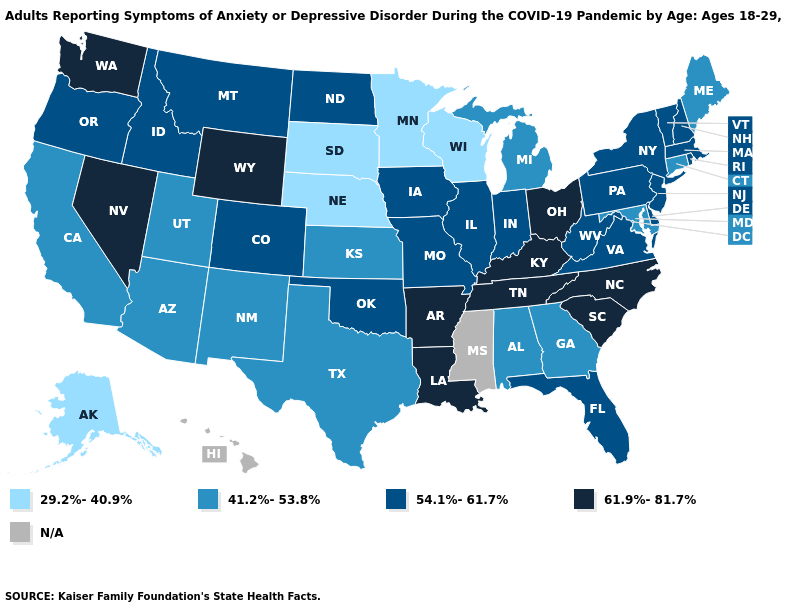What is the lowest value in the Northeast?
Keep it brief. 41.2%-53.8%. Which states have the lowest value in the USA?
Give a very brief answer. Alaska, Minnesota, Nebraska, South Dakota, Wisconsin. Which states have the lowest value in the USA?
Short answer required. Alaska, Minnesota, Nebraska, South Dakota, Wisconsin. Name the states that have a value in the range 54.1%-61.7%?
Give a very brief answer. Colorado, Delaware, Florida, Idaho, Illinois, Indiana, Iowa, Massachusetts, Missouri, Montana, New Hampshire, New Jersey, New York, North Dakota, Oklahoma, Oregon, Pennsylvania, Rhode Island, Vermont, Virginia, West Virginia. What is the highest value in the Northeast ?
Give a very brief answer. 54.1%-61.7%. What is the value of Hawaii?
Be succinct. N/A. Among the states that border Arizona , does Nevada have the lowest value?
Short answer required. No. Among the states that border Indiana , which have the lowest value?
Write a very short answer. Michigan. Is the legend a continuous bar?
Give a very brief answer. No. Among the states that border Rhode Island , which have the lowest value?
Answer briefly. Connecticut. Name the states that have a value in the range 54.1%-61.7%?
Answer briefly. Colorado, Delaware, Florida, Idaho, Illinois, Indiana, Iowa, Massachusetts, Missouri, Montana, New Hampshire, New Jersey, New York, North Dakota, Oklahoma, Oregon, Pennsylvania, Rhode Island, Vermont, Virginia, West Virginia. What is the value of North Dakota?
Short answer required. 54.1%-61.7%. What is the highest value in the USA?
Keep it brief. 61.9%-81.7%. How many symbols are there in the legend?
Give a very brief answer. 5. 